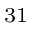<formula> <loc_0><loc_0><loc_500><loc_500>^ { 3 1 }</formula> 